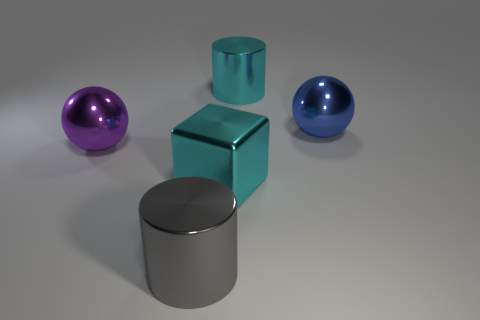Add 3 big blue matte cylinders. How many objects exist? 8 Subtract all spheres. How many objects are left? 3 Subtract all big cyan cylinders. Subtract all big spheres. How many objects are left? 2 Add 3 big cyan cylinders. How many big cyan cylinders are left? 4 Add 5 tiny matte cylinders. How many tiny matte cylinders exist? 5 Subtract 0 yellow cylinders. How many objects are left? 5 